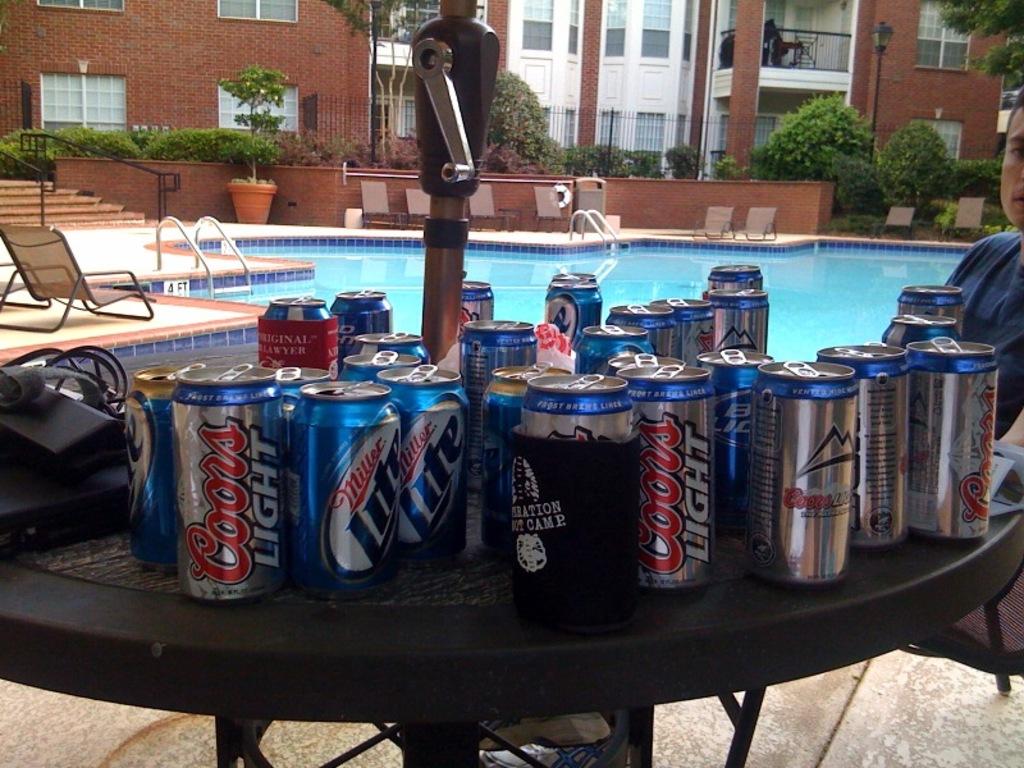How many different brands of beer are there here?
Your answer should be very brief. 2. What brand is the can on the far left?
Ensure brevity in your answer.  Coors light. 